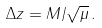<formula> <loc_0><loc_0><loc_500><loc_500>\Delta z = M / \sqrt { \mu } \, .</formula> 